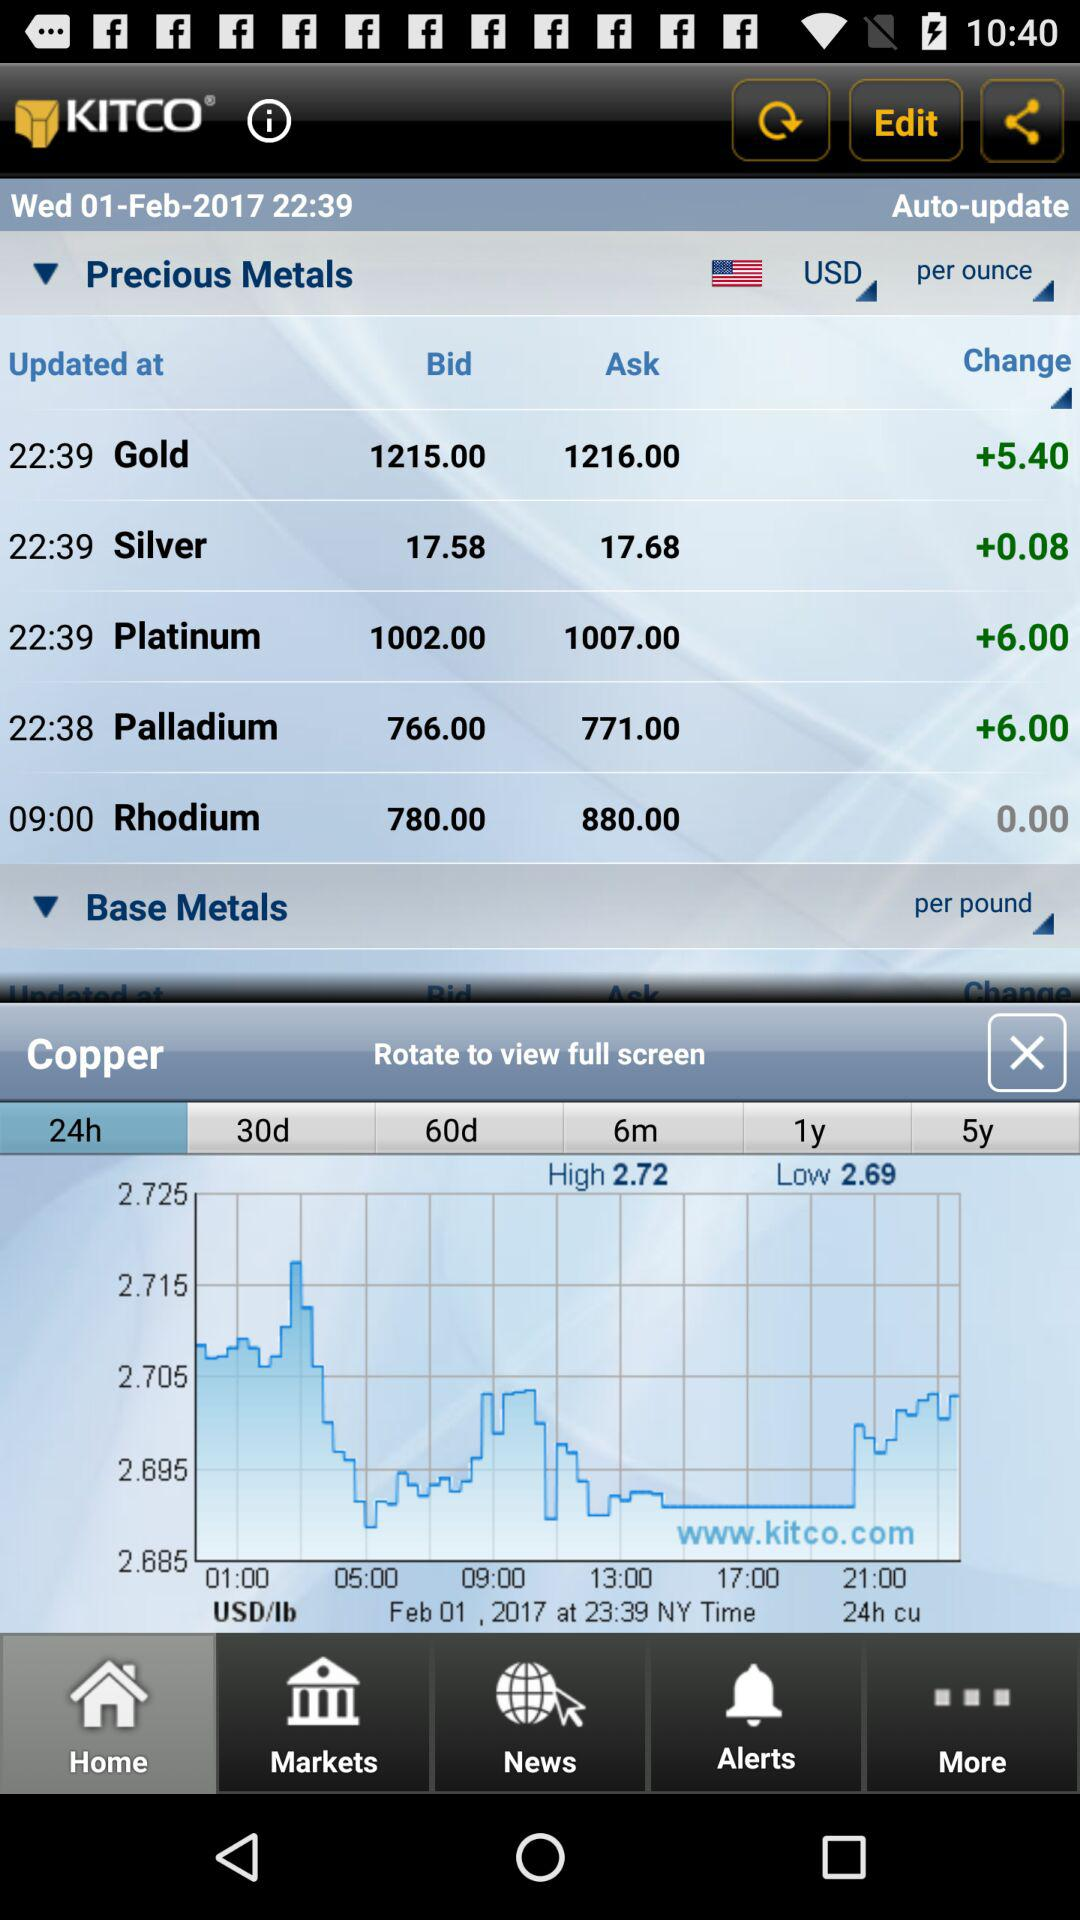Which currency options are available?
When the provided information is insufficient, respond with <no answer>. <no answer> 